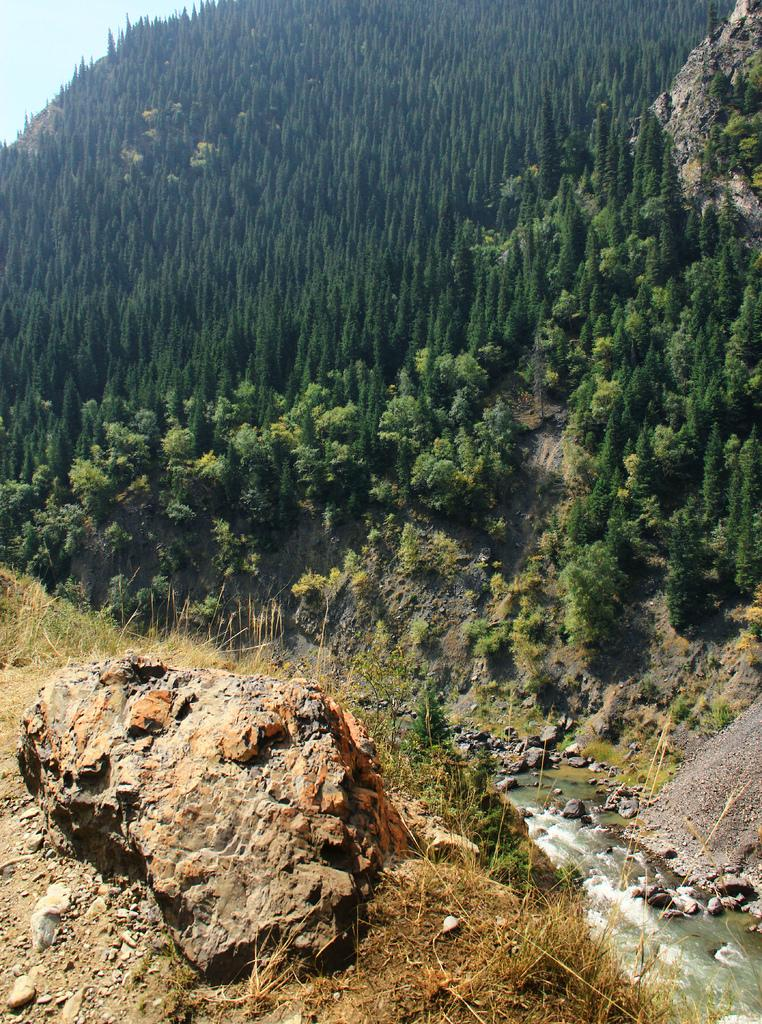What type of vegetation is in the front of the image? There is dry grass in the front of the image. What object can also be found in the front of the image? There is a stone in the front of the image. What can be seen in the background of the image? There are trees and stones in the background of the image. What natural element is visible in the background of the image? There is water visible in the background of the image. What type of pen is floating on the water in the background of the image? There is no pen present in the image; it only features dry grass, a stone, trees, stones, and water. How many stars can be seen in the image? There are no stars visible in the image. 